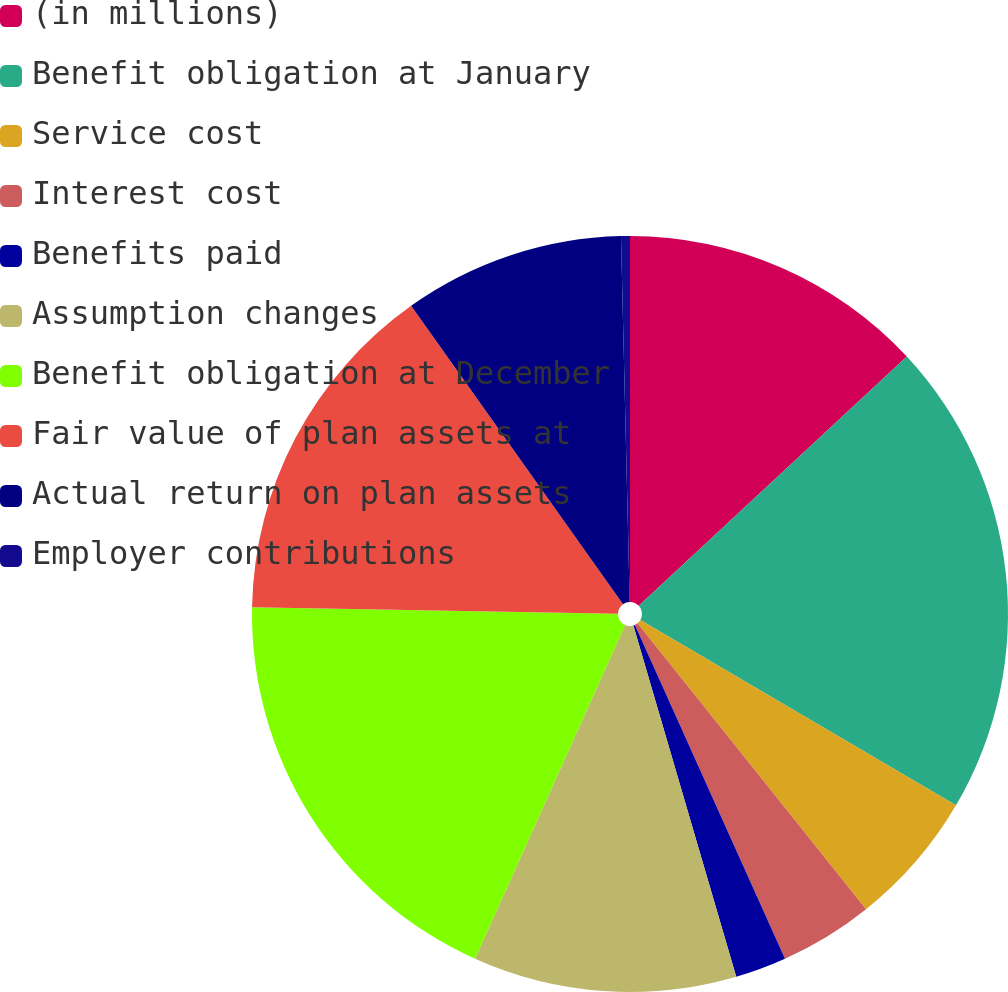Convert chart. <chart><loc_0><loc_0><loc_500><loc_500><pie_chart><fcel>(in millions)<fcel>Benefit obligation at January<fcel>Service cost<fcel>Interest cost<fcel>Benefits paid<fcel>Assumption changes<fcel>Benefit obligation at December<fcel>Fair value of plan assets at<fcel>Actual return on plan assets<fcel>Employer contributions<nl><fcel>13.08%<fcel>20.37%<fcel>5.82%<fcel>4.01%<fcel>2.19%<fcel>11.26%<fcel>18.56%<fcel>14.89%<fcel>9.45%<fcel>0.38%<nl></chart> 